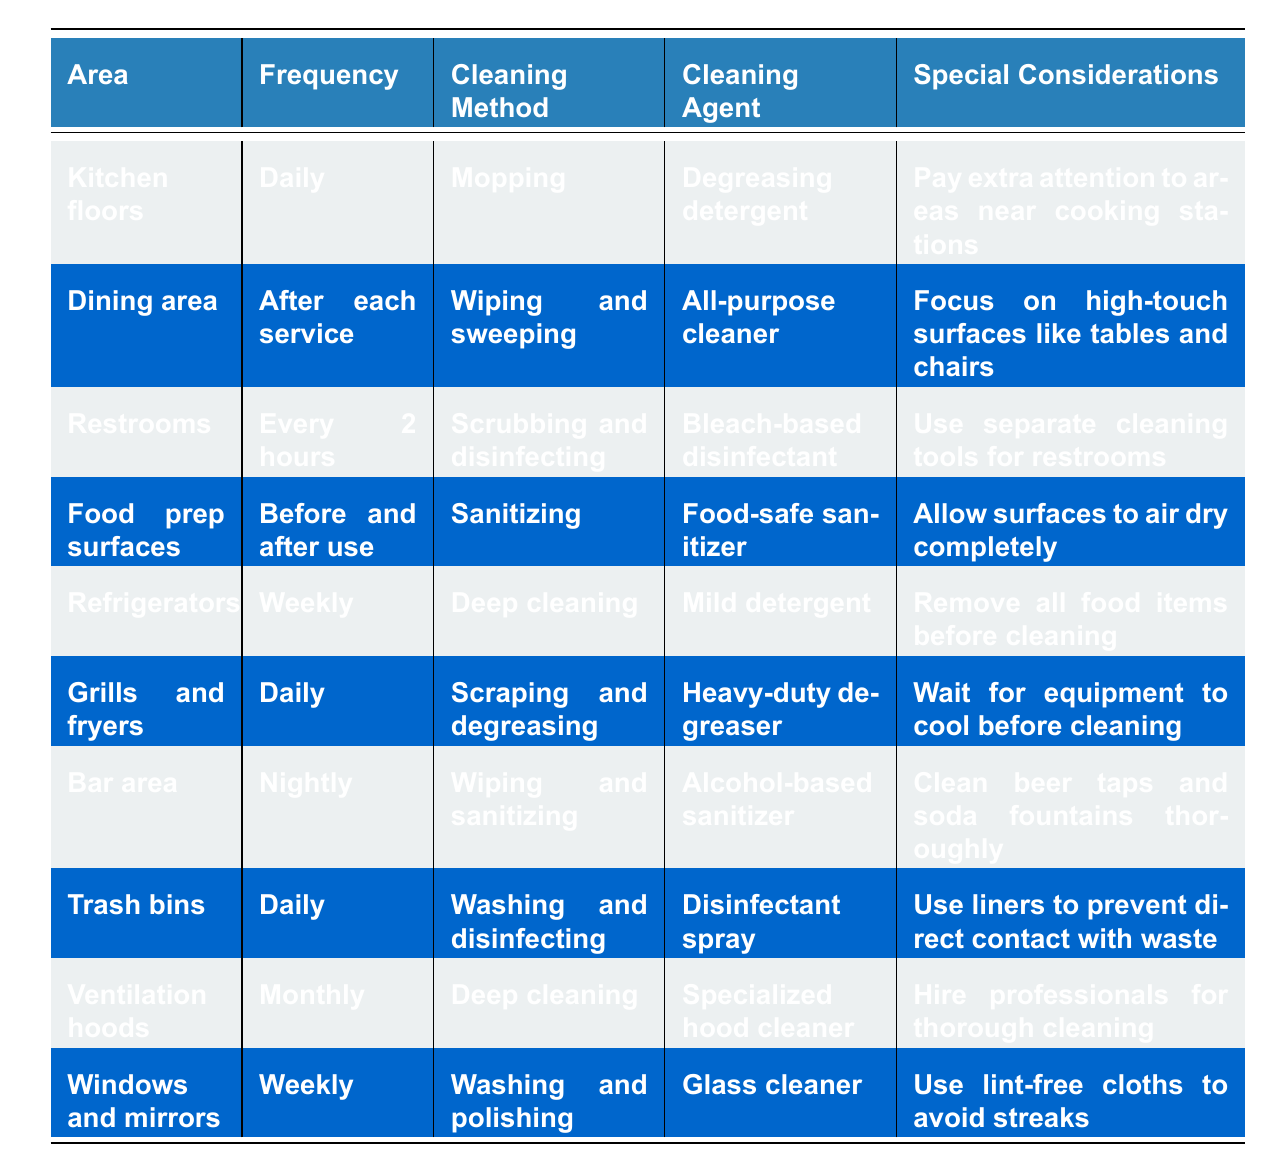What is the cleaning method for kitchen floors? The table clearly states that the cleaning method for kitchen floors is mopping.
Answer: Mopping How often should the dining area be cleaned? According to the table, the dining area needs to be cleaned after each service.
Answer: After each service Is it necessary to use separate cleaning tools for restrooms? The table mentions under special considerations that it is necessary to use separate cleaning tools for restrooms.
Answer: Yes What cleaning agent is recommended for food prep surfaces? The table indicates that a food-safe sanitizer is the recommended cleaning agent for food prep surfaces.
Answer: Food-safe sanitizer How many areas in the restaurant are cleaned daily? The table shows that there are four areas cleaned daily: kitchen floors, grills and fryers, bar area, and trash bins. This totals to four areas.
Answer: Four areas What is the frequency of cleaning for refrigerators? The table lists the frequency of cleaning for refrigerators as weekly.
Answer: Weekly Should grills and fryers be cleaned after they cool down? Yes, the table specifies that grilling and frying equipment should wait for cooling before cleaning.
Answer: Yes Which area has the highest frequency of cleaning listed? Upon examining the table, restrooms are cleaned every 2 hours, which is the highest frequency listed.
Answer: Restrooms What type of cleaning is recommended for the bar area? The table specifies that the cleaning method for the bar area is wiping and sanitizing.
Answer: Wiping and sanitizing How many cleaning agents are used for cleaning surfaces? The table shows that five different cleaning agents are used for various surfaces: degreasing detergent, all-purpose cleaner, bleach-based disinfectant, food-safe sanitizer, and mild detergent.
Answer: Five cleaning agents What is the special consideration for cleaning windows and mirrors? The table notes that a special consideration when cleaning windows and mirrors is to use lint-free cloths to avoid streaks.
Answer: Use lint-free cloths to avoid streaks What is the average frequency of cleaning for all listed areas? The frequencies of cleaning include daily (4), after each service (1), every 2 hours (1), before and after use (1), weekly (3), and monthly (1). Converting to hours: 1 daily = 24 hours; 1 after each service (assumed 2 hours) = 2; 1 every 2 hours = 2; 1 before and after use = 0 (on average); 1 weekly = 168 hours; and 1 monthly = 720 hours. Summing these gives approx 918 hours for 12 total cleaning schedules. Dividing by the number of areas gives an average of about 76.5 hours.
Answer: Approximately 76.5 hours What is the cleaning method for the ventilation hoods? The table indicates that the cleaning method for ventilation hoods is deep cleaning.
Answer: Deep cleaning What are the special considerations for cleaning trash bins? The table states that for trash bins, the special considerations include using liners to prevent direct contact with waste.
Answer: Use liners to prevent direct contact with waste 